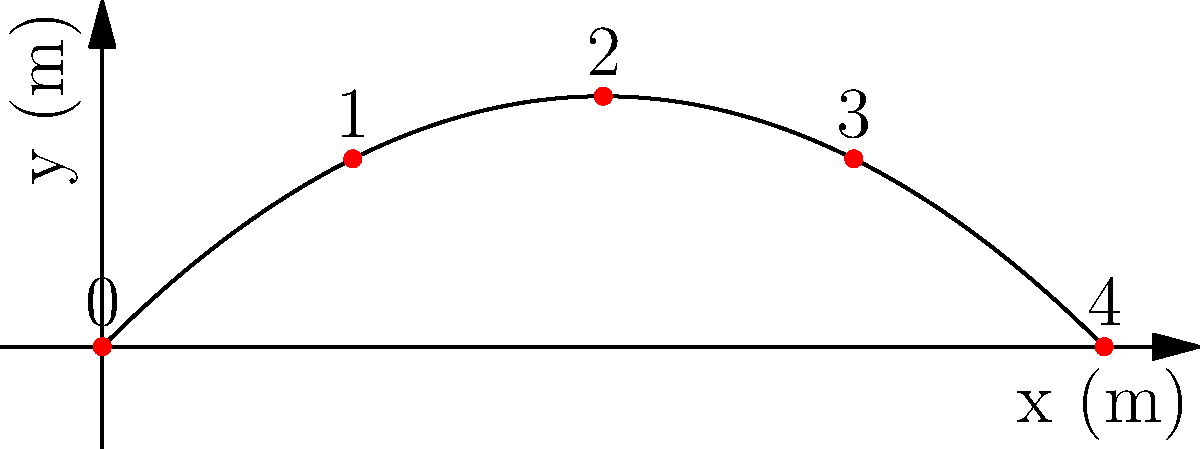As a supportive older brother helping his sister understand projectile motion, you're explaining a diagram showing the trajectory of a ball thrown at a 45-degree angle. The initial velocity is 20 m/s, and time intervals are marked from 0 to 4. At which marked time interval does the ball reach its maximum height? Let's approach this step-by-step:

1) In projectile motion, the vertical component of velocity ($v_y$) determines when the object reaches its maximum height.

2) The initial vertical velocity is:
   $v_{y0} = v_0 \sin(\theta) = 20 \sin(45°) = 20 \cdot \frac{\sqrt{2}}{2} \approx 14.14$ m/s

3) The time to reach maximum height is when $v_y = 0$. We can find this using:
   $v_y = v_{y0} - gt$
   $0 = 14.14 - 9.8t$
   $t = \frac{14.14}{9.8} \approx 1.44$ seconds

4) The total time of flight is twice this:
   $t_{total} = 2 \cdot 1.44 = 2.88$ seconds

5) In the diagram, we see 5 points marked from 0 to 4, evenly spaced in time.
   Each interval represents $\frac{2.88}{4} = 0.72$ seconds.

6) The maximum height occurs at 1.44 seconds, which is exactly at the midpoint of the flight.

7) This midpoint corresponds to the mark labeled "2" in the diagram.

Therefore, the ball reaches its maximum height at the time interval marked 2.
Answer: 2 